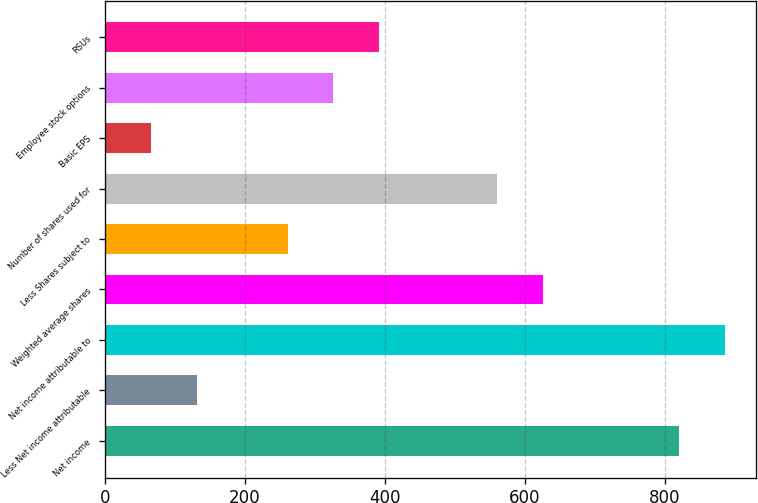Convert chart. <chart><loc_0><loc_0><loc_500><loc_500><bar_chart><fcel>Net income<fcel>Less Net income attributable<fcel>Net income attributable to<fcel>Weighted average shares<fcel>Less Shares subject to<fcel>Number of shares used for<fcel>Basic EPS<fcel>Employee stock options<fcel>RSUs<nl><fcel>821.36<fcel>131.28<fcel>886.45<fcel>626.09<fcel>261.46<fcel>561<fcel>66.19<fcel>326.55<fcel>391.64<nl></chart> 